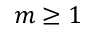Convert formula to latex. <formula><loc_0><loc_0><loc_500><loc_500>m \geq 1</formula> 